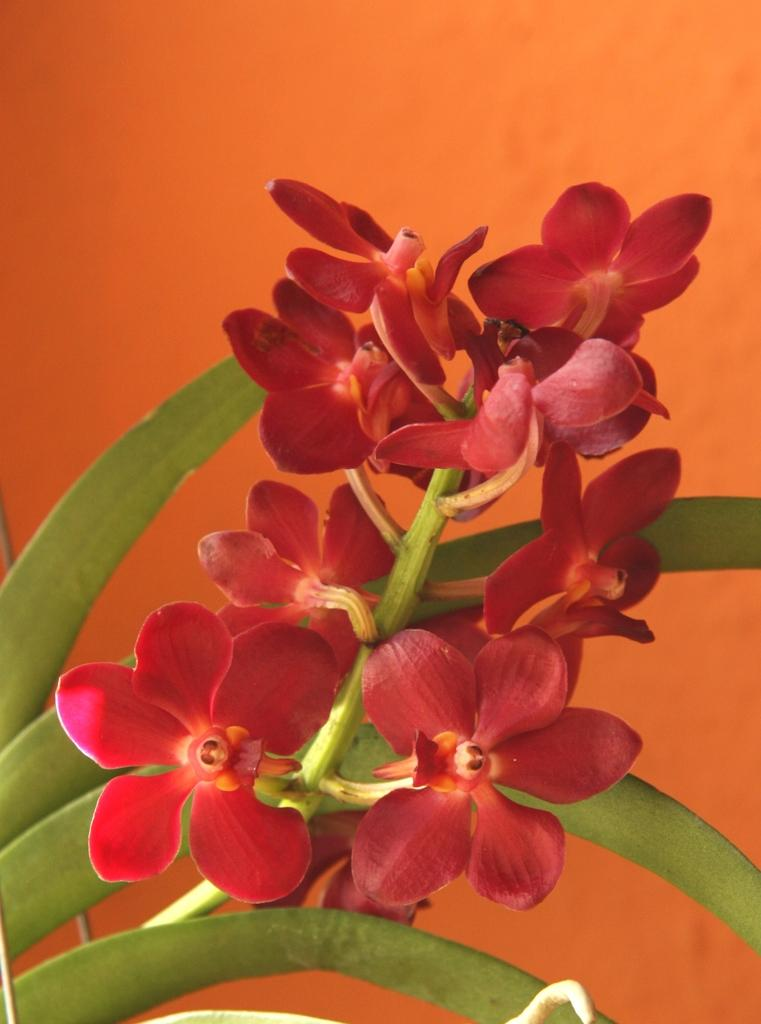What type of flowers can be seen on the plant in the image? There are red flowers on a plant in the image. What color is the background of the image? The background color is orange. How many bikes are parked next to the plant in the image? There are no bikes present in the image. What type of base is supporting the plant in the image? The image does not show a base supporting the plant; it only shows the plant and flowers. 